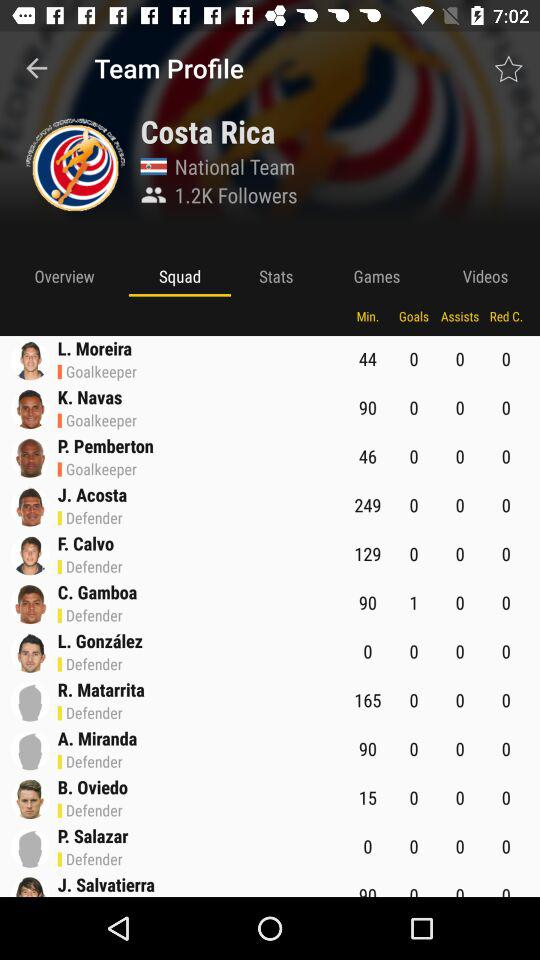How many followers are there? There are 1.2K followers. 